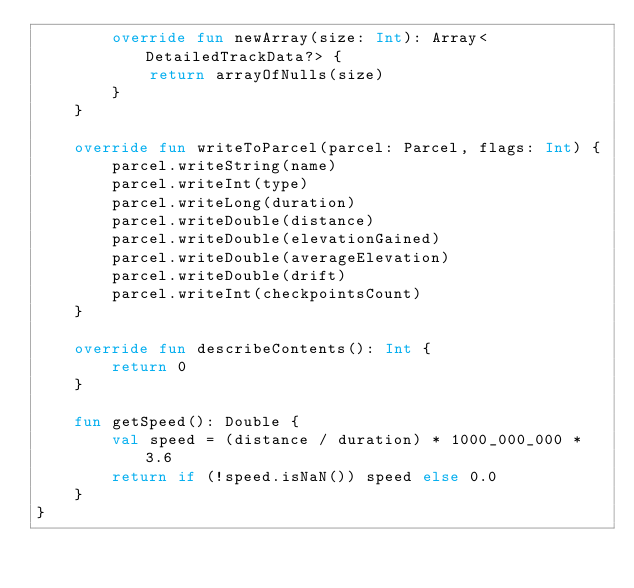Convert code to text. <code><loc_0><loc_0><loc_500><loc_500><_Kotlin_>        override fun newArray(size: Int): Array<DetailedTrackData?> {
            return arrayOfNulls(size)
        }
    }

    override fun writeToParcel(parcel: Parcel, flags: Int) {
        parcel.writeString(name)
        parcel.writeInt(type)
        parcel.writeLong(duration)
        parcel.writeDouble(distance)
        parcel.writeDouble(elevationGained)
        parcel.writeDouble(averageElevation)
        parcel.writeDouble(drift)
        parcel.writeInt(checkpointsCount)
    }

    override fun describeContents(): Int {
        return 0
    }

    fun getSpeed(): Double {
        val speed = (distance / duration) * 1000_000_000 * 3.6
        return if (!speed.isNaN()) speed else 0.0
    }
}</code> 